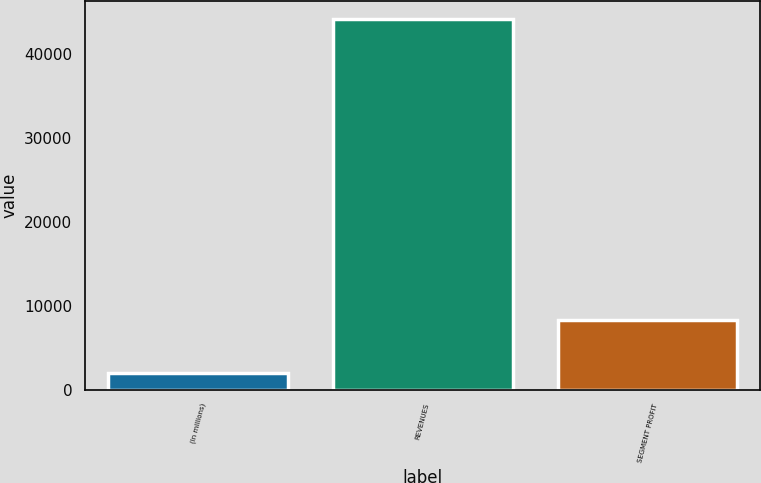Convert chart. <chart><loc_0><loc_0><loc_500><loc_500><bar_chart><fcel>(In millions)<fcel>REVENUES<fcel>SEGMENT PROFIT<nl><fcel>2013<fcel>44067<fcel>8258<nl></chart> 